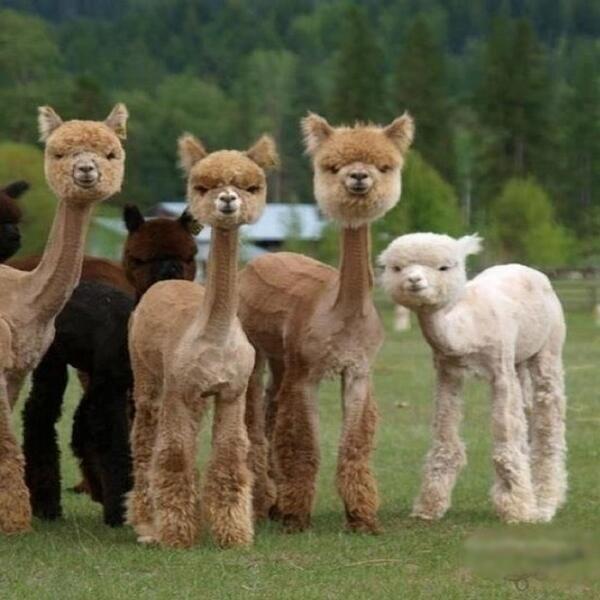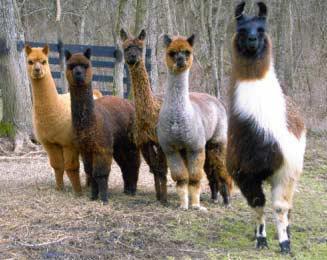The first image is the image on the left, the second image is the image on the right. Examine the images to the left and right. Is the description "One of the images shows a llama with multicolored yarn decorations hanging from its ears." accurate? Answer yes or no. No. 